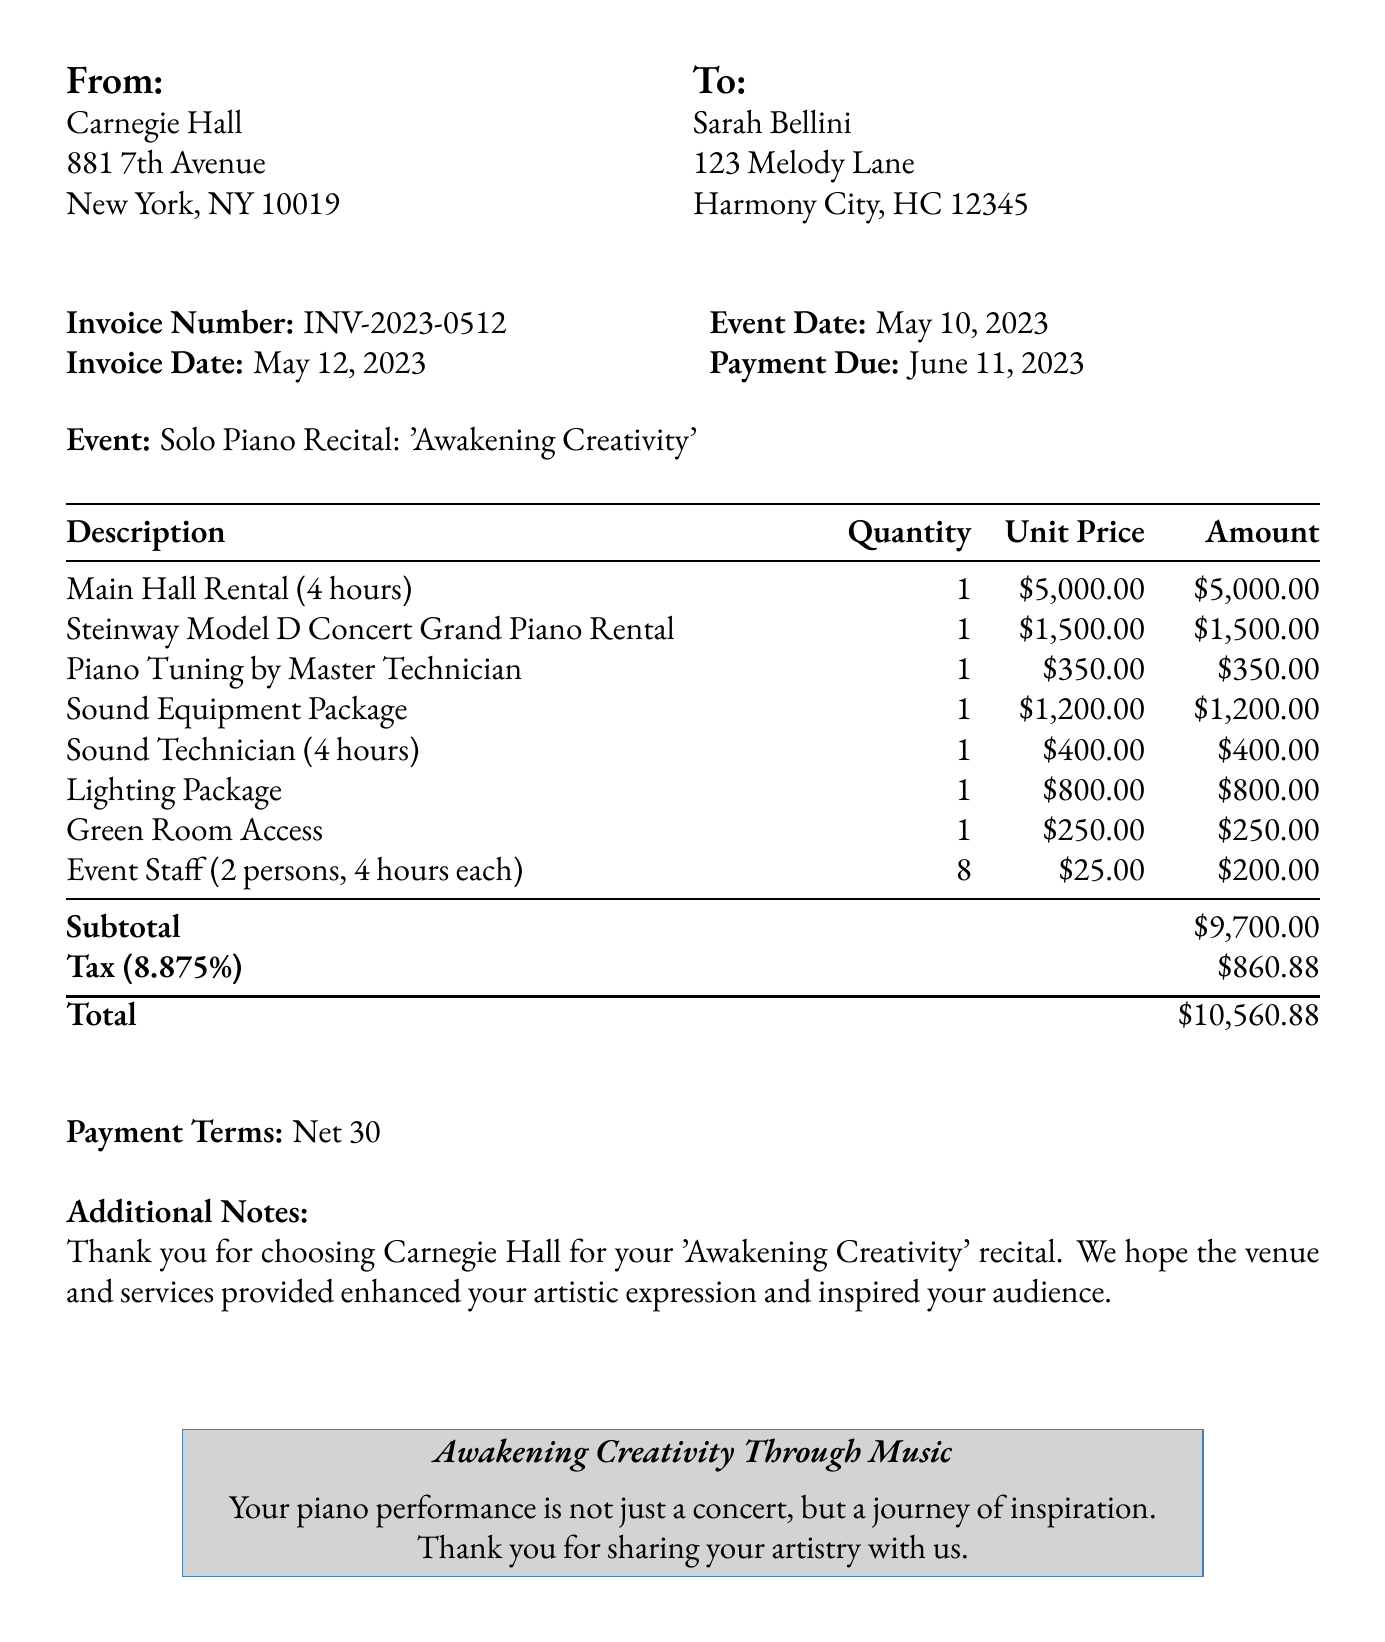What is the invoice number? The invoice number is specified in the document as a unique identifier, which is INV-2023-0512.
Answer: INV-2023-0512 Who is the client? The client name is provided in the document, which is Sarah Bellini.
Answer: Sarah Bellini What date is the invoice issued? The invoice date is listed in the document, which is 2023-05-12.
Answer: 2023-05-12 What is the total amount due? The total amount due is listed at the bottom of the invoice and is 10,560.88.
Answer: 10,560.88 How many hours was the main hall rented? The main hall rental duration is mentioned in the document as 4 hours.
Answer: 4 hours What is the quantity of the event staff? The document specifies that there are 8 event staff members required for the event.
Answer: 8 What is the tax rate applied? The tax rate is stated in the document as 8.875 percent.
Answer: 8.875% What payment terms are mentioned? The document specifies the payment terms as Net 30, indicating payment is due within 30 days.
Answer: Net 30 What event took place on May 10, 2023? The document describes the event as a Solo Piano Recital titled 'Awakening Creativity'.
Answer: Solo Piano Recital: 'Awakening Creativity' 